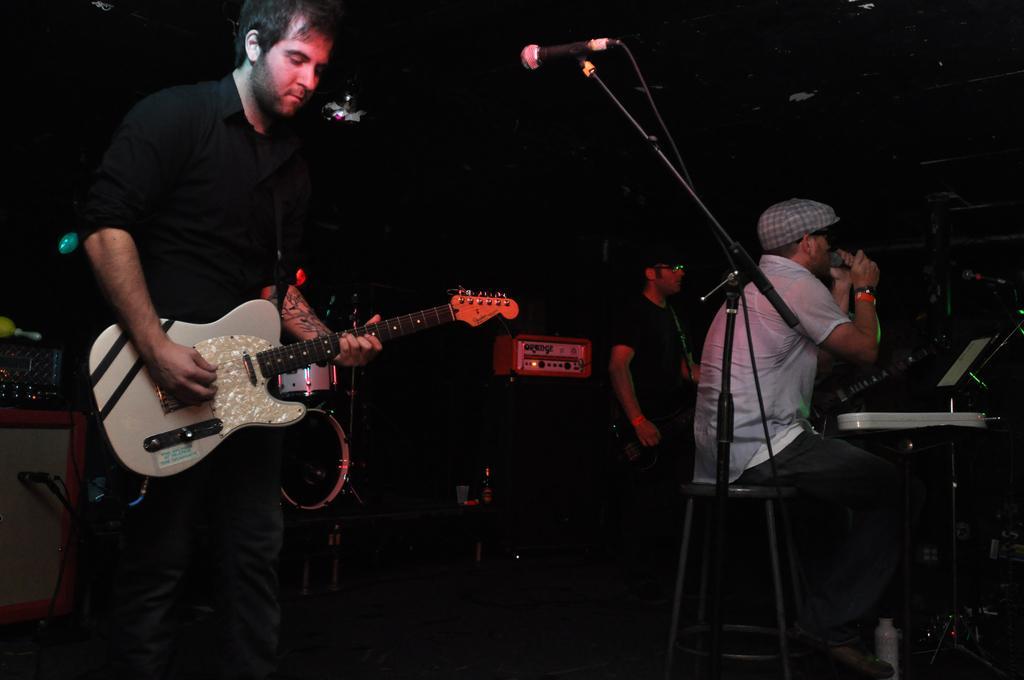Could you give a brief overview of what you see in this image? The picture is clicked in a musical concert where a guy who is wearing black shirt is playing a guitar and singing with a mic placed in front of him. In the background we also observe two guys playing musical instruments. In the background there are many boxes which are sound systems and other musical instruments. 